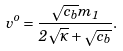<formula> <loc_0><loc_0><loc_500><loc_500>v ^ { o } = \frac { \sqrt { c _ { b } } m _ { 1 } } { 2 \sqrt { \varkappa } + \sqrt { c _ { b } } } .</formula> 